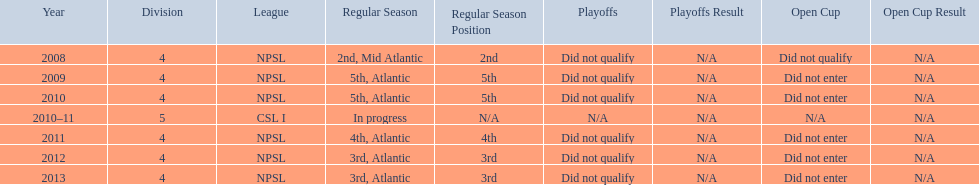Would you mind parsing the complete table? {'header': ['Year', 'Division', 'League', 'Regular Season', 'Regular Season Position', 'Playoffs', 'Playoffs Result', 'Open Cup', 'Open Cup Result'], 'rows': [['2008', '4', 'NPSL', '2nd, Mid Atlantic', '2nd', 'Did not qualify', 'N/A', 'Did not qualify', 'N/A'], ['2009', '4', 'NPSL', '5th, Atlantic', '5th', 'Did not qualify', 'N/A', 'Did not enter', 'N/A'], ['2010', '4', 'NPSL', '5th, Atlantic', '5th', 'Did not qualify', 'N/A', 'Did not enter', 'N/A'], ['2010–11', '5', 'CSL I', 'In progress', 'N/A', 'N/A', 'N/A', 'N/A', 'N/A'], ['2011', '4', 'NPSL', '4th, Atlantic', '4th', 'Did not qualify', 'N/A', 'Did not enter', 'N/A'], ['2012', '4', 'NPSL', '3rd, Atlantic', '3rd', 'Did not qualify', 'N/A', 'Did not enter', 'N/A'], ['2013', '4', 'NPSL', '3rd, Atlantic', '3rd', 'Did not qualify', 'N/A', 'Did not enter', 'N/A']]} What are the leagues? NPSL, NPSL, NPSL, CSL I, NPSL, NPSL, NPSL. Of these, what league is not npsl? CSL I. 